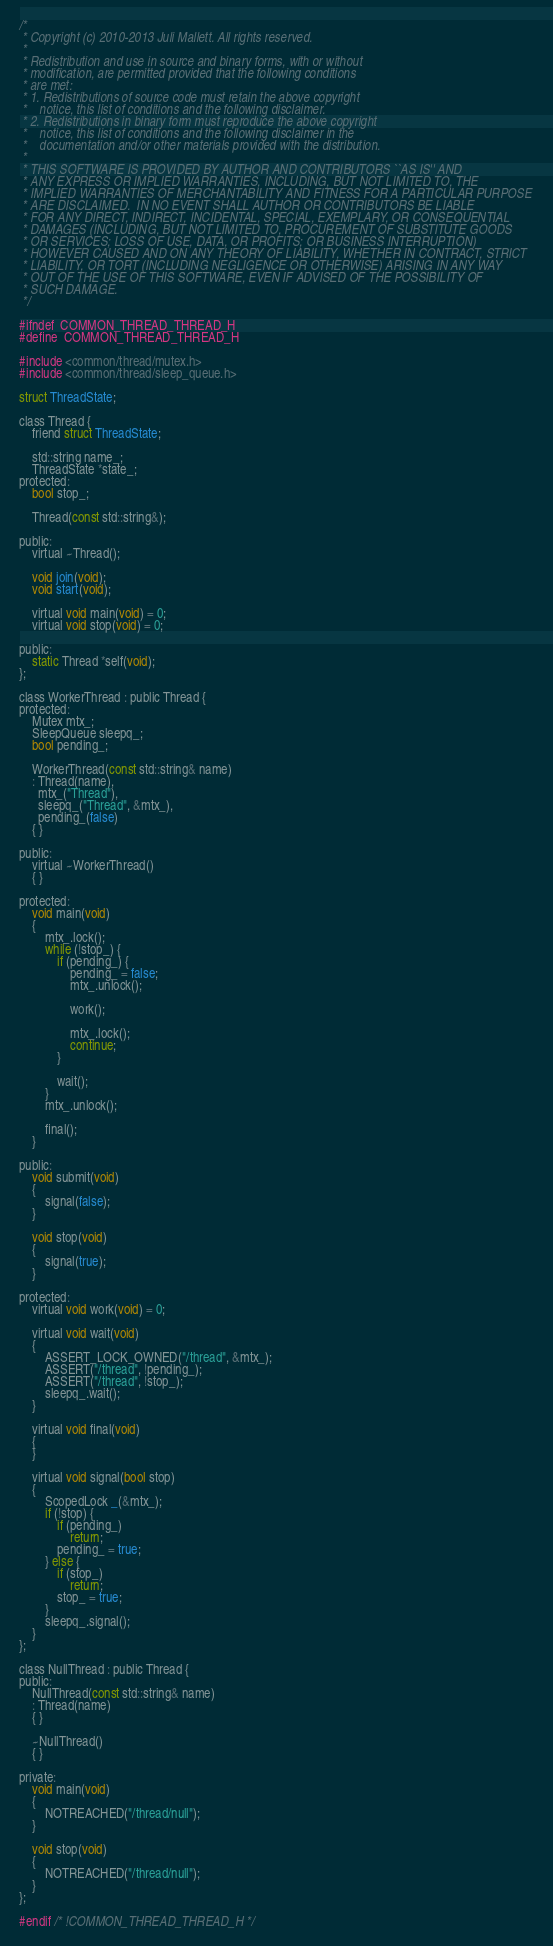Convert code to text. <code><loc_0><loc_0><loc_500><loc_500><_C_>/*
 * Copyright (c) 2010-2013 Juli Mallett. All rights reserved.
 *
 * Redistribution and use in source and binary forms, with or without
 * modification, are permitted provided that the following conditions
 * are met:
 * 1. Redistributions of source code must retain the above copyright
 *    notice, this list of conditions and the following disclaimer.
 * 2. Redistributions in binary form must reproduce the above copyright
 *    notice, this list of conditions and the following disclaimer in the
 *    documentation and/or other materials provided with the distribution.
 *
 * THIS SOFTWARE IS PROVIDED BY AUTHOR AND CONTRIBUTORS ``AS IS'' AND
 * ANY EXPRESS OR IMPLIED WARRANTIES, INCLUDING, BUT NOT LIMITED TO, THE
 * IMPLIED WARRANTIES OF MERCHANTABILITY AND FITNESS FOR A PARTICULAR PURPOSE
 * ARE DISCLAIMED.  IN NO EVENT SHALL AUTHOR OR CONTRIBUTORS BE LIABLE
 * FOR ANY DIRECT, INDIRECT, INCIDENTAL, SPECIAL, EXEMPLARY, OR CONSEQUENTIAL
 * DAMAGES (INCLUDING, BUT NOT LIMITED TO, PROCUREMENT OF SUBSTITUTE GOODS
 * OR SERVICES; LOSS OF USE, DATA, OR PROFITS; OR BUSINESS INTERRUPTION)
 * HOWEVER CAUSED AND ON ANY THEORY OF LIABILITY, WHETHER IN CONTRACT, STRICT
 * LIABILITY, OR TORT (INCLUDING NEGLIGENCE OR OTHERWISE) ARISING IN ANY WAY
 * OUT OF THE USE OF THIS SOFTWARE, EVEN IF ADVISED OF THE POSSIBILITY OF
 * SUCH DAMAGE.
 */

#ifndef	COMMON_THREAD_THREAD_H
#define	COMMON_THREAD_THREAD_H

#include <common/thread/mutex.h>
#include <common/thread/sleep_queue.h>

struct ThreadState;

class Thread {
	friend struct ThreadState;

	std::string name_;
	ThreadState *state_;
protected:
	bool stop_;

	Thread(const std::string&);

public:
	virtual ~Thread();

	void join(void);
	void start(void);

	virtual void main(void) = 0;
	virtual void stop(void) = 0;

public:
	static Thread *self(void);
};

class WorkerThread : public Thread {
protected:
	Mutex mtx_;
	SleepQueue sleepq_;
	bool pending_;

	WorkerThread(const std::string& name)
	: Thread(name),
	  mtx_("Thread"),
	  sleepq_("Thread", &mtx_),
	  pending_(false)
	{ }

public:
	virtual ~WorkerThread()
	{ }

protected:
	void main(void)
	{
		mtx_.lock();
		while (!stop_) {
			if (pending_) {
				pending_ = false;
				mtx_.unlock();

				work();

				mtx_.lock();
				continue;
			}

			wait();
		}
		mtx_.unlock();

		final();
	}

public:
	void submit(void)
	{
		signal(false);
	}

	void stop(void)
	{
		signal(true);
	}

protected:
	virtual void work(void) = 0;

	virtual void wait(void)
	{
		ASSERT_LOCK_OWNED("/thread", &mtx_);
		ASSERT("/thread", !pending_);
		ASSERT("/thread", !stop_);
		sleepq_.wait();
	}

	virtual void final(void)
	{
	}

	virtual void signal(bool stop)
	{
		ScopedLock _(&mtx_);
		if (!stop) {
			if (pending_)
				return;
			pending_ = true;
		} else {
			if (stop_)
				return;
			stop_ = true;
		}
		sleepq_.signal();
	}
};

class NullThread : public Thread {
public:
	NullThread(const std::string& name)
	: Thread(name)
	{ }

	~NullThread()
	{ }

private:
	void main(void)
	{
		NOTREACHED("/thread/null");
	}

	void stop(void)
	{
		NOTREACHED("/thread/null");
	}
};

#endif /* !COMMON_THREAD_THREAD_H */
</code> 